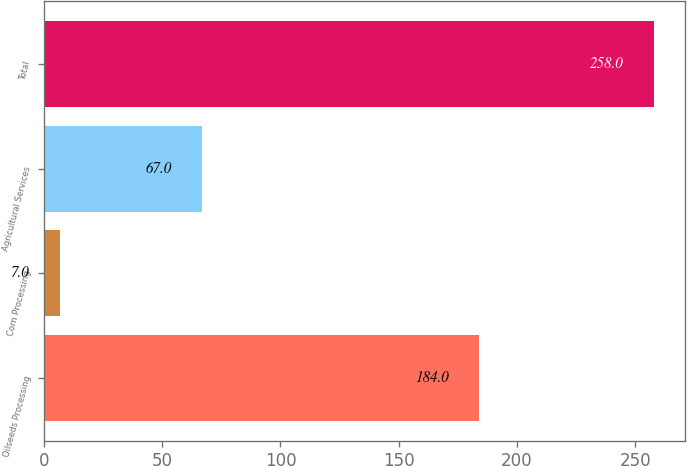Convert chart. <chart><loc_0><loc_0><loc_500><loc_500><bar_chart><fcel>Oilseeds Processing<fcel>Corn Processing<fcel>Agricultural Services<fcel>Total<nl><fcel>184<fcel>7<fcel>67<fcel>258<nl></chart> 